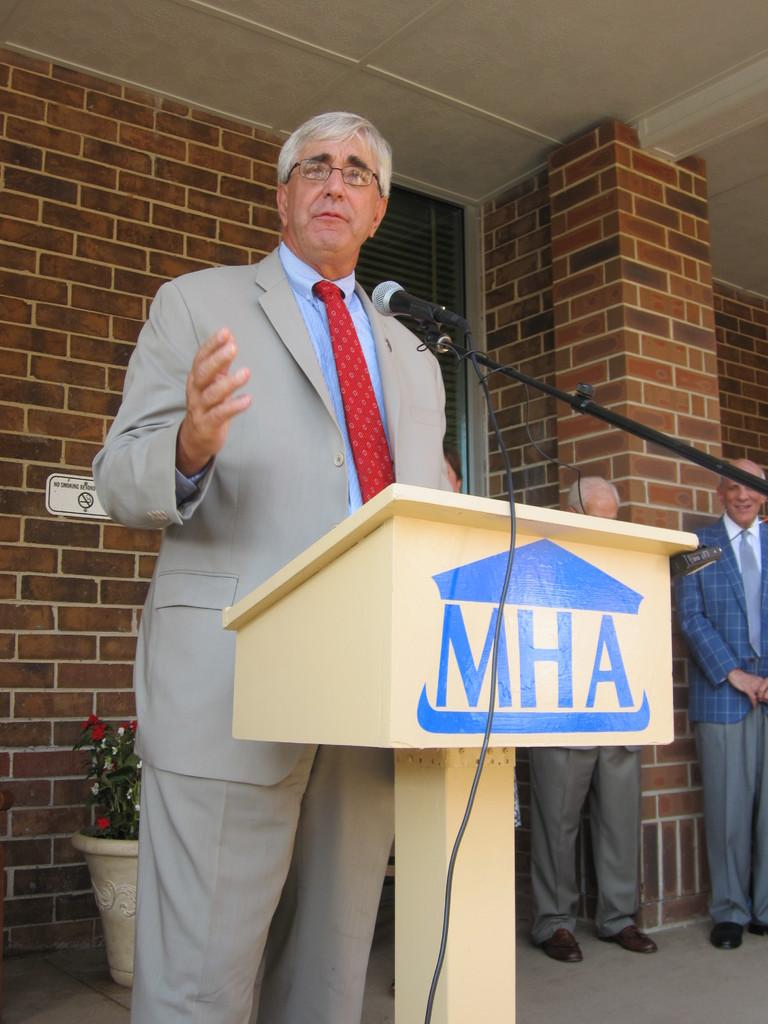What is the man in the image doing? The man is standing at the lectern in the image. What is attached to the lectern? A microphone is fixed to the lectern. What can be seen in the background of the image? Walls and a house plant are visible in the background of the image. Are there any other people in the image? Yes, there are men standing on the floor in the background of the image. What type of collar can be seen on the house plant in the image? There is no collar present on the house plant in the image; it is a plant and does not wear clothing. 